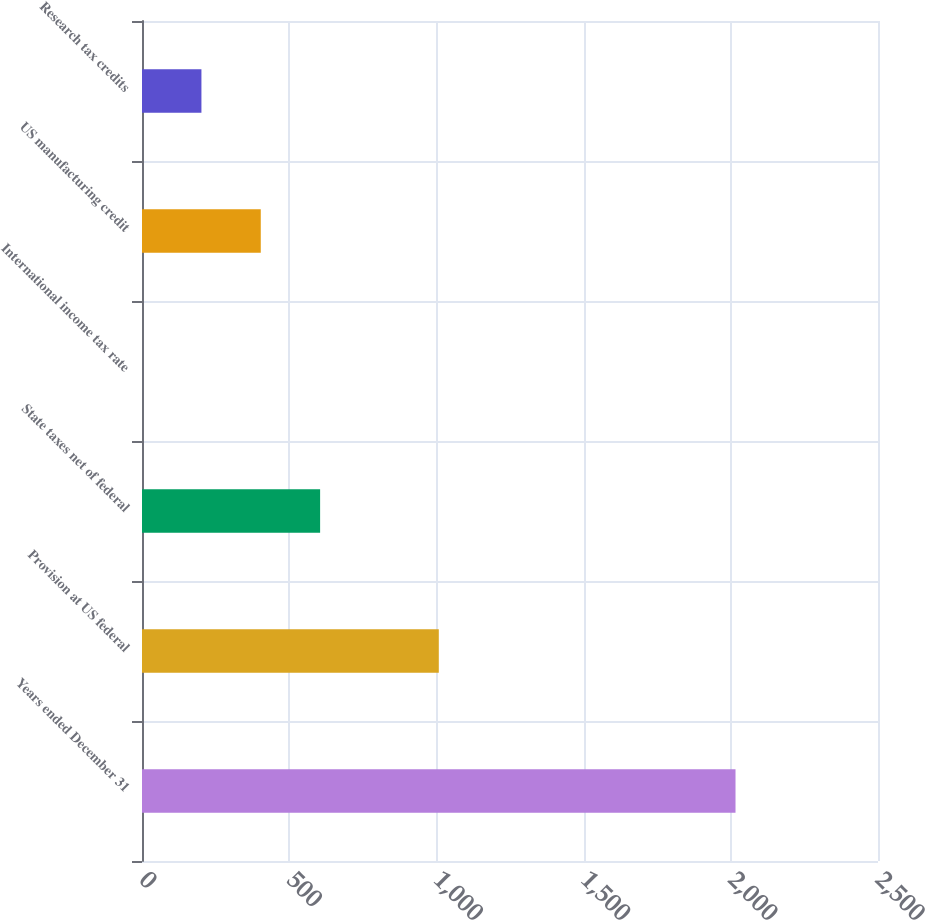<chart> <loc_0><loc_0><loc_500><loc_500><bar_chart><fcel>Years ended December 31<fcel>Provision at US federal<fcel>State taxes net of federal<fcel>International income tax rate<fcel>US manufacturing credit<fcel>Research tax credits<nl><fcel>2016<fcel>1008.15<fcel>605.01<fcel>0.3<fcel>403.44<fcel>201.87<nl></chart> 